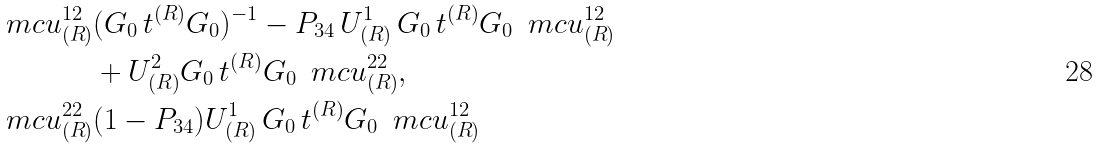Convert formula to latex. <formula><loc_0><loc_0><loc_500><loc_500>\ m c u ^ { 1 2 } _ { ( R ) } & ( G _ { 0 } \, t ^ { ( R ) } G _ { 0 } ) ^ { - 1 } - P _ { 3 4 } \, U ^ { 1 } _ { ( R ) } \, G _ { 0 } \, t ^ { ( R ) } G _ { 0 } \, \ m c u ^ { 1 2 } _ { ( R ) } \\ & + { U } ^ { 2 } _ { ( R ) } G _ { 0 } \, t ^ { ( R ) } G _ { 0 } \, \ m c u ^ { 2 2 } _ { ( R ) } , \\ \ m c u ^ { 2 2 } _ { ( R ) } & ( 1 - P _ { 3 4 } ) U ^ { 1 } _ { ( R ) } \, G _ { 0 } \, t ^ { ( R ) } G _ { 0 } \, \ m c u ^ { 1 2 } _ { ( R ) }</formula> 